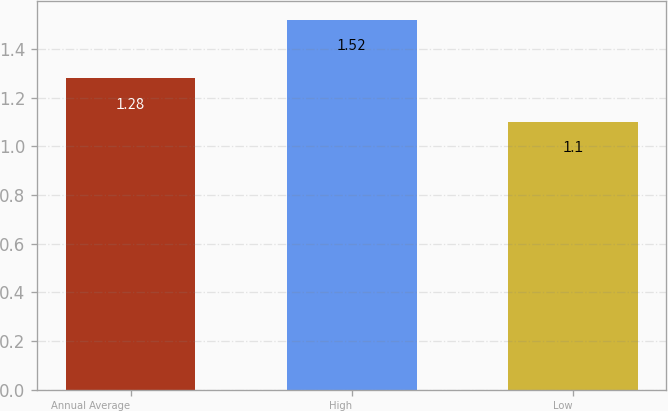Convert chart to OTSL. <chart><loc_0><loc_0><loc_500><loc_500><bar_chart><fcel>Annual Average<fcel>High<fcel>Low<nl><fcel>1.28<fcel>1.52<fcel>1.1<nl></chart> 